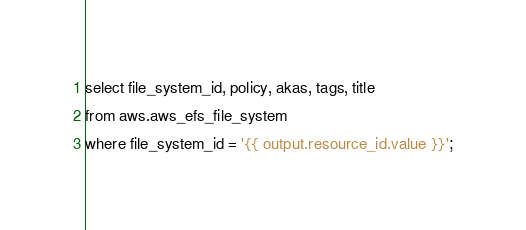Convert code to text. <code><loc_0><loc_0><loc_500><loc_500><_SQL_>select file_system_id, policy, akas, tags, title
from aws.aws_efs_file_system
where file_system_id = '{{ output.resource_id.value }}';</code> 